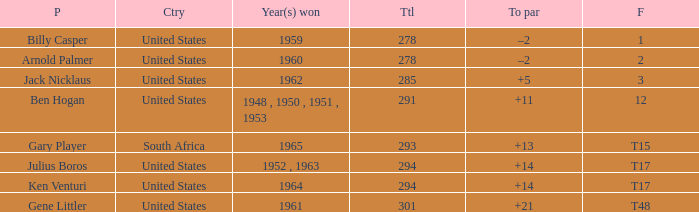What is the year(s) achieved when the total is below 285? 1959, 1960. 